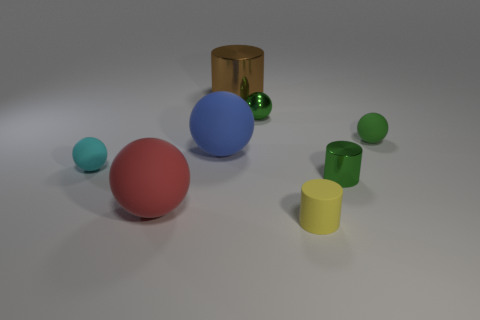Subtract all metallic spheres. How many spheres are left? 4 Subtract all cyan spheres. How many spheres are left? 4 Subtract 5 spheres. How many spheres are left? 0 Add 2 tiny yellow rubber cylinders. How many objects exist? 10 Subtract all balls. How many objects are left? 3 Add 4 cyan rubber things. How many cyan rubber things are left? 5 Add 1 green spheres. How many green spheres exist? 3 Subtract 0 brown blocks. How many objects are left? 8 Subtract all purple cylinders. Subtract all brown cubes. How many cylinders are left? 3 Subtract all blue cubes. How many gray balls are left? 0 